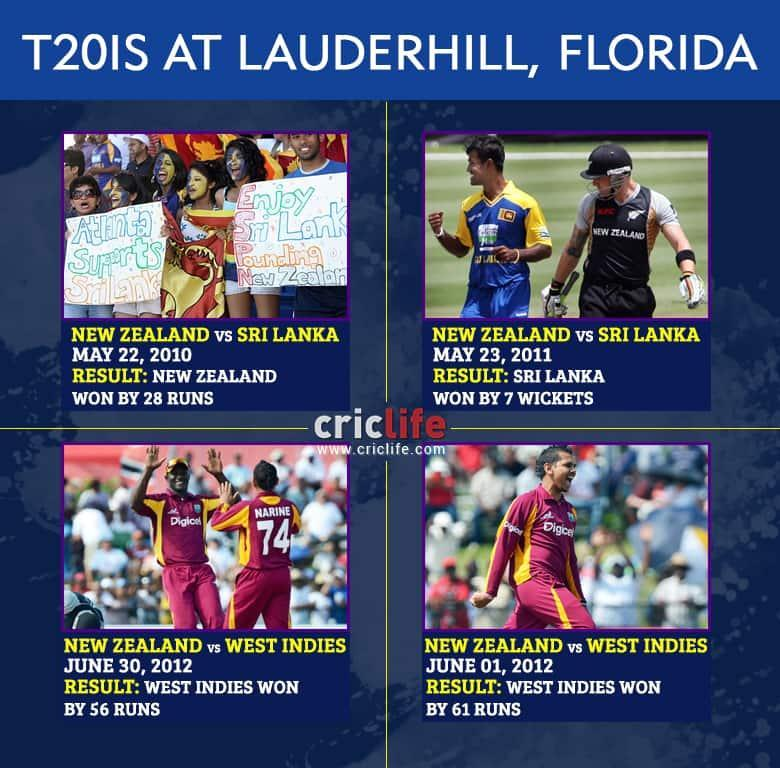How many games won by West Indies?
Answer the question with a short phrase. 2 How many games won by New Zealand? 1 